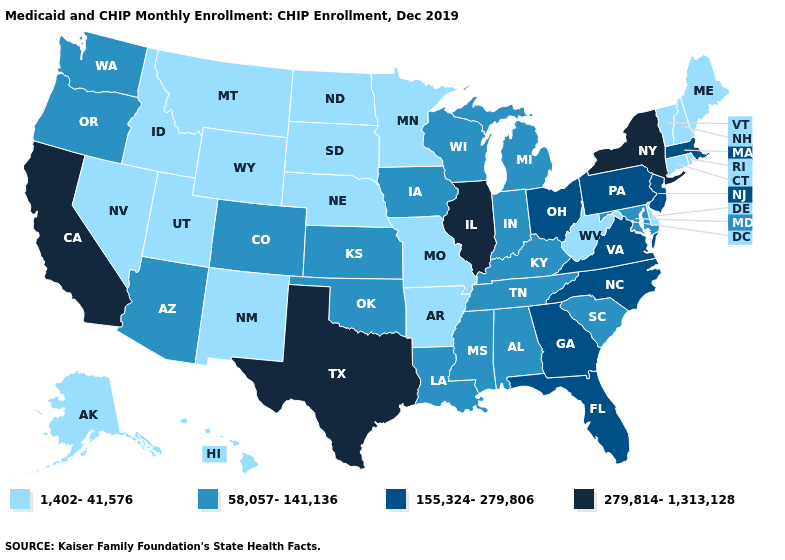Among the states that border Arizona , which have the highest value?
Quick response, please. California. Which states hav the highest value in the MidWest?
Write a very short answer. Illinois. Does New York have the highest value in the Northeast?
Short answer required. Yes. What is the lowest value in the USA?
Answer briefly. 1,402-41,576. What is the value of Kansas?
Give a very brief answer. 58,057-141,136. Does Arizona have the highest value in the West?
Give a very brief answer. No. What is the lowest value in states that border Texas?
Keep it brief. 1,402-41,576. What is the highest value in the South ?
Short answer required. 279,814-1,313,128. What is the highest value in states that border Pennsylvania?
Answer briefly. 279,814-1,313,128. Name the states that have a value in the range 58,057-141,136?
Be succinct. Alabama, Arizona, Colorado, Indiana, Iowa, Kansas, Kentucky, Louisiana, Maryland, Michigan, Mississippi, Oklahoma, Oregon, South Carolina, Tennessee, Washington, Wisconsin. What is the highest value in states that border Vermont?
Give a very brief answer. 279,814-1,313,128. Name the states that have a value in the range 155,324-279,806?
Keep it brief. Florida, Georgia, Massachusetts, New Jersey, North Carolina, Ohio, Pennsylvania, Virginia. What is the lowest value in the USA?
Answer briefly. 1,402-41,576. Does the first symbol in the legend represent the smallest category?
Quick response, please. Yes. Does Mississippi have a higher value than Nevada?
Write a very short answer. Yes. 